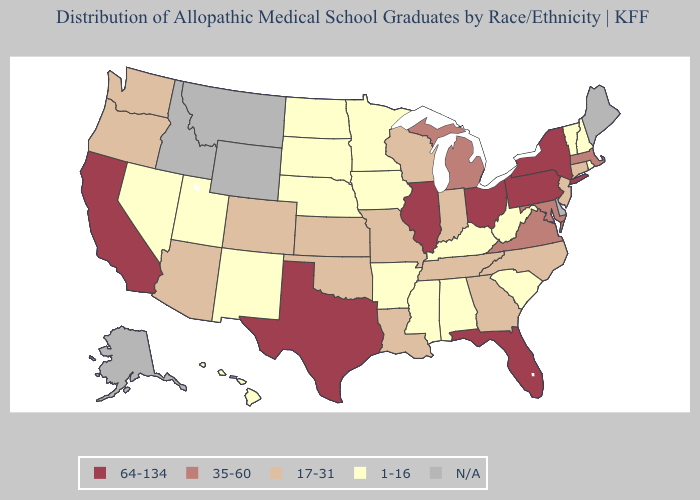Does New York have the lowest value in the Northeast?
Give a very brief answer. No. Among the states that border Texas , which have the highest value?
Be succinct. Louisiana, Oklahoma. Among the states that border Wyoming , which have the highest value?
Be succinct. Colorado. What is the value of Colorado?
Concise answer only. 17-31. What is the value of Vermont?
Be succinct. 1-16. Which states have the lowest value in the USA?
Write a very short answer. Alabama, Arkansas, Hawaii, Iowa, Kentucky, Minnesota, Mississippi, Nebraska, Nevada, New Hampshire, New Mexico, North Dakota, Rhode Island, South Carolina, South Dakota, Utah, Vermont, West Virginia. Which states have the lowest value in the South?
Quick response, please. Alabama, Arkansas, Kentucky, Mississippi, South Carolina, West Virginia. Which states hav the highest value in the South?
Short answer required. Florida, Texas. How many symbols are there in the legend?
Keep it brief. 5. What is the lowest value in states that border Wyoming?
Write a very short answer. 1-16. Does the map have missing data?
Be succinct. Yes. Among the states that border California , which have the lowest value?
Concise answer only. Nevada. Which states have the lowest value in the USA?
Quick response, please. Alabama, Arkansas, Hawaii, Iowa, Kentucky, Minnesota, Mississippi, Nebraska, Nevada, New Hampshire, New Mexico, North Dakota, Rhode Island, South Carolina, South Dakota, Utah, Vermont, West Virginia. What is the highest value in the MidWest ?
Quick response, please. 64-134. 